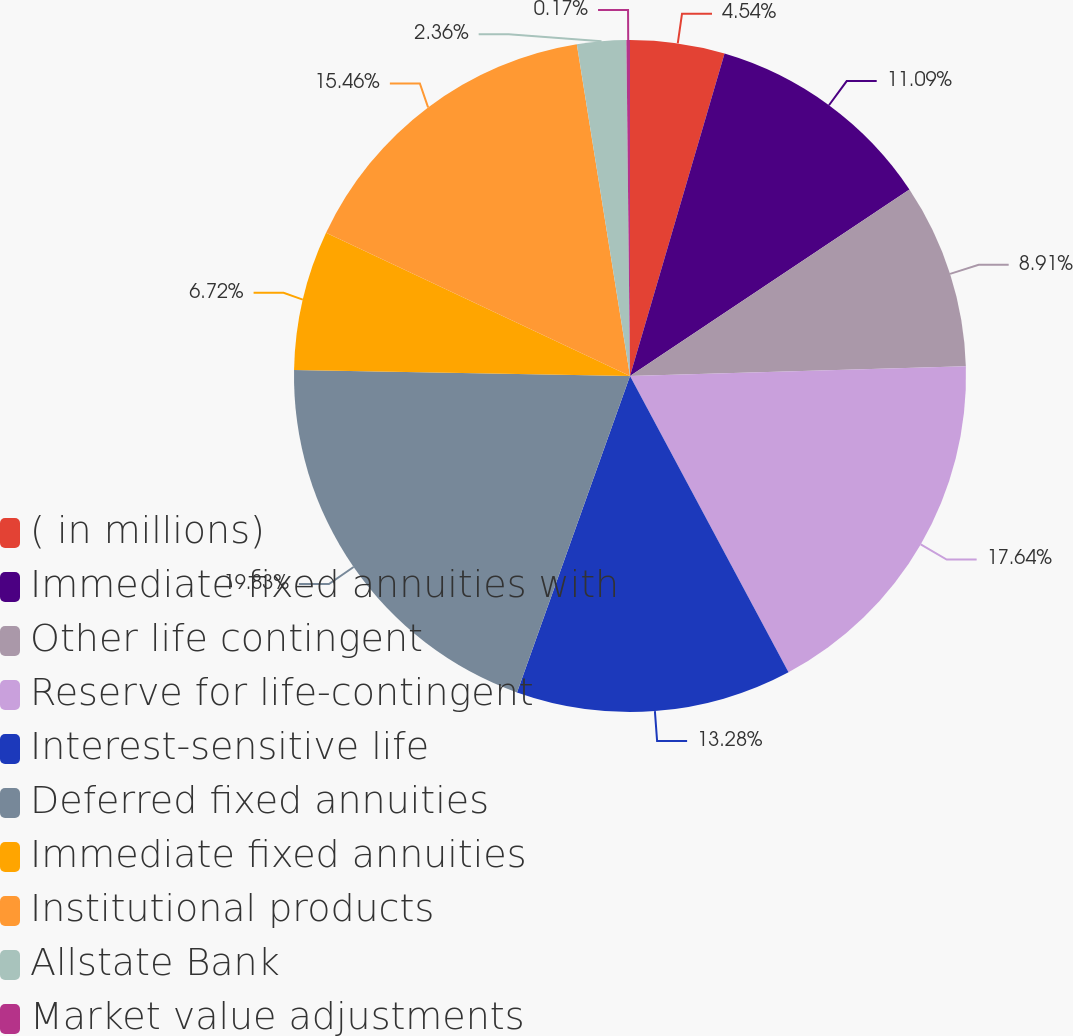Convert chart. <chart><loc_0><loc_0><loc_500><loc_500><pie_chart><fcel>( in millions)<fcel>Immediate fixed annuities with<fcel>Other life contingent<fcel>Reserve for life-contingent<fcel>Interest-sensitive life<fcel>Deferred fixed annuities<fcel>Immediate fixed annuities<fcel>Institutional products<fcel>Allstate Bank<fcel>Market value adjustments<nl><fcel>4.54%<fcel>11.09%<fcel>8.91%<fcel>17.64%<fcel>13.28%<fcel>19.83%<fcel>6.72%<fcel>15.46%<fcel>2.36%<fcel>0.17%<nl></chart> 